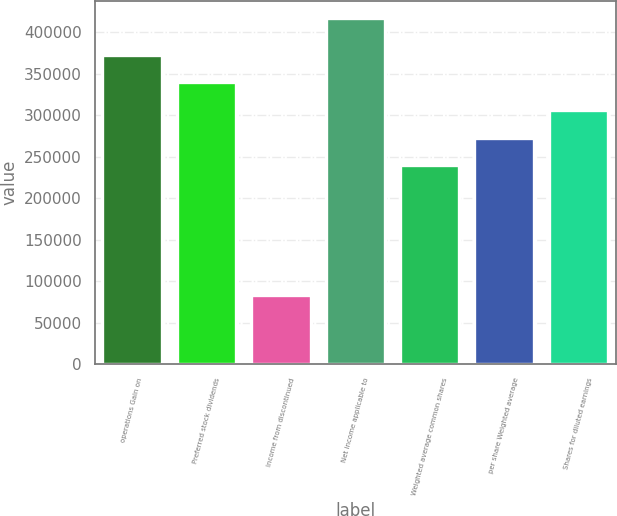Convert chart. <chart><loc_0><loc_0><loc_500><loc_500><bar_chart><fcel>operations Gain on<fcel>Preferred stock dividends<fcel>Income from discontinued<fcel>Net income applicable to<fcel>Weighted average common shares<fcel>per share Weighted average<fcel>Shares for diluted earnings<nl><fcel>372949<fcel>339600<fcel>83128<fcel>416621<fcel>239552<fcel>272901<fcel>306251<nl></chart> 